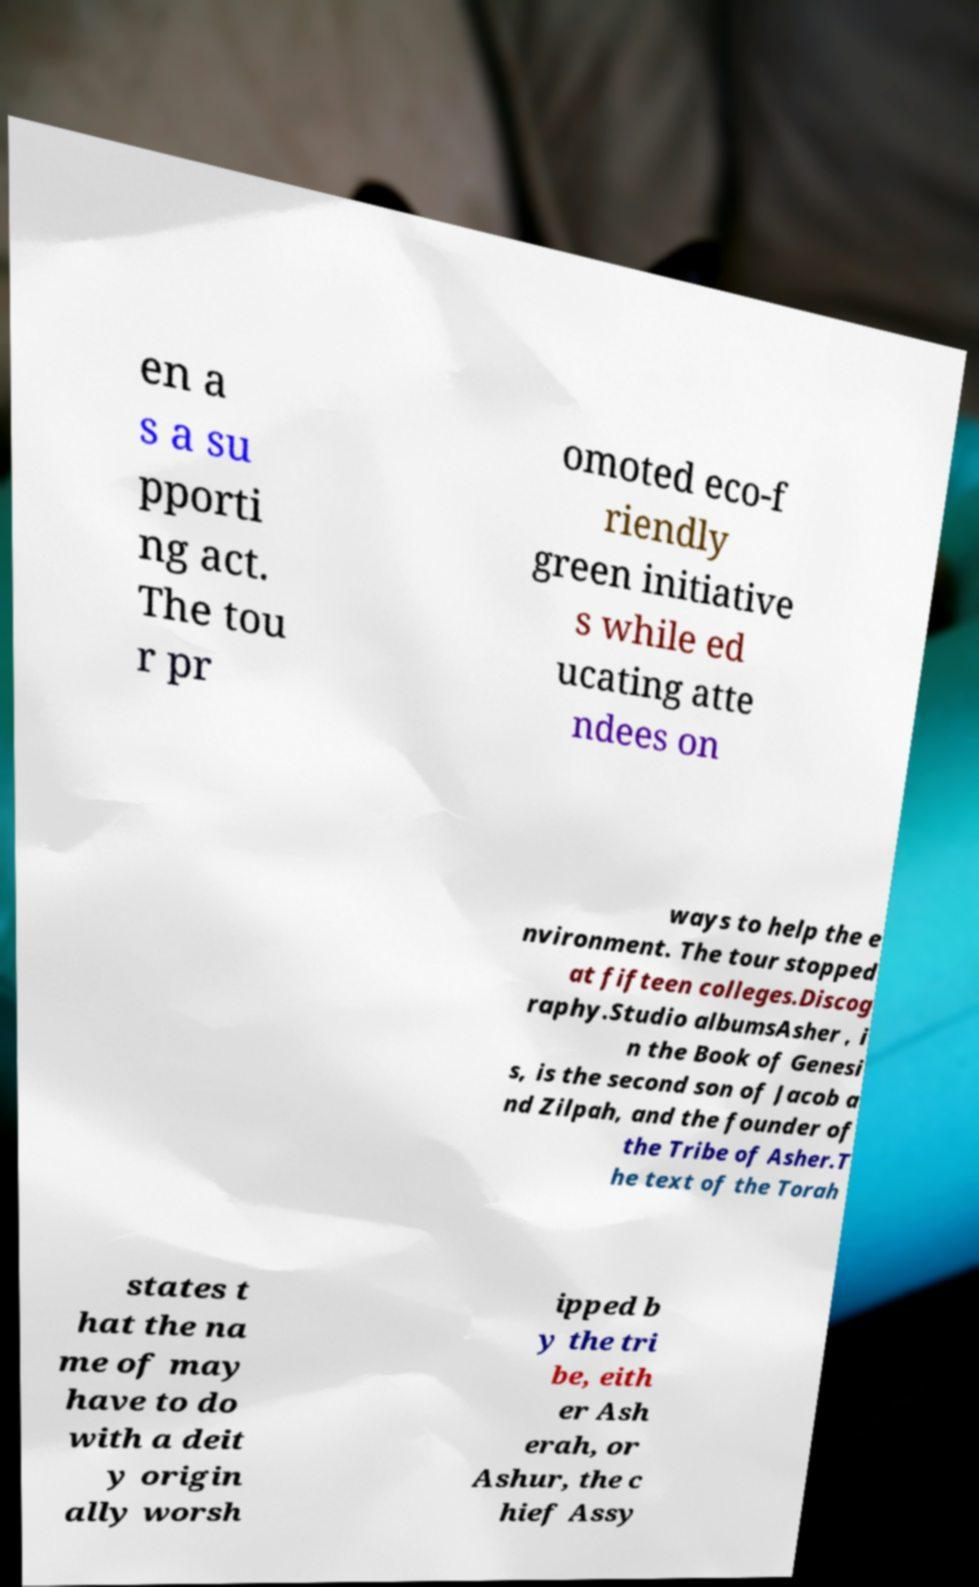Please identify and transcribe the text found in this image. en a s a su pporti ng act. The tou r pr omoted eco-f riendly green initiative s while ed ucating atte ndees on ways to help the e nvironment. The tour stopped at fifteen colleges.Discog raphy.Studio albumsAsher , i n the Book of Genesi s, is the second son of Jacob a nd Zilpah, and the founder of the Tribe of Asher.T he text of the Torah states t hat the na me of may have to do with a deit y origin ally worsh ipped b y the tri be, eith er Ash erah, or Ashur, the c hief Assy 